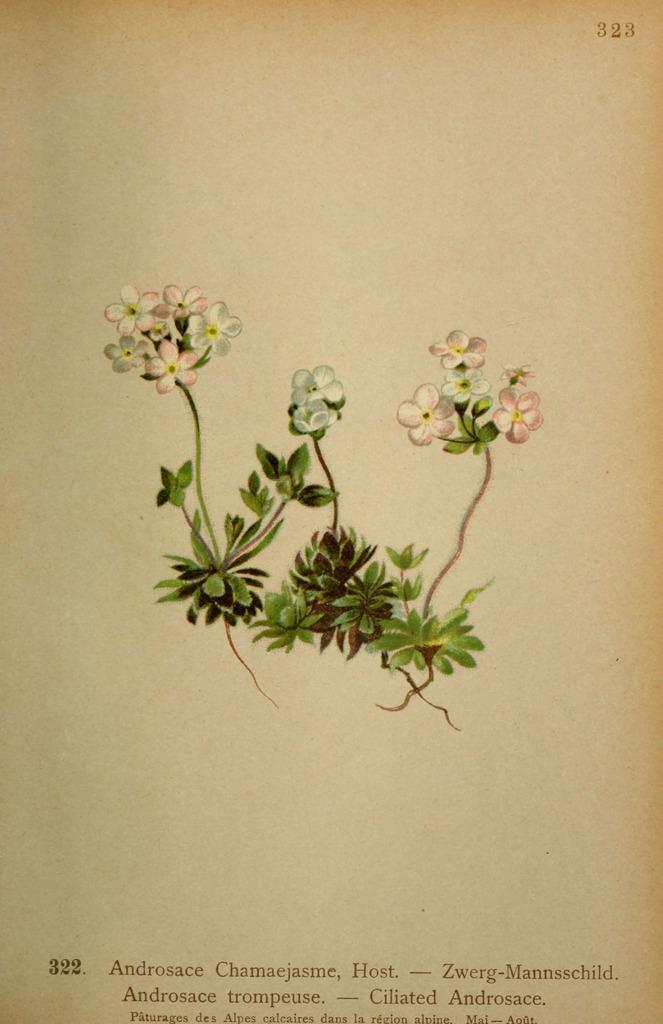Please provide a concise description of this image. In this image I can see a paper, on the paper I can see few flowers, they are in pink and white color. I can also see leaves in green color and something written on the paper. 